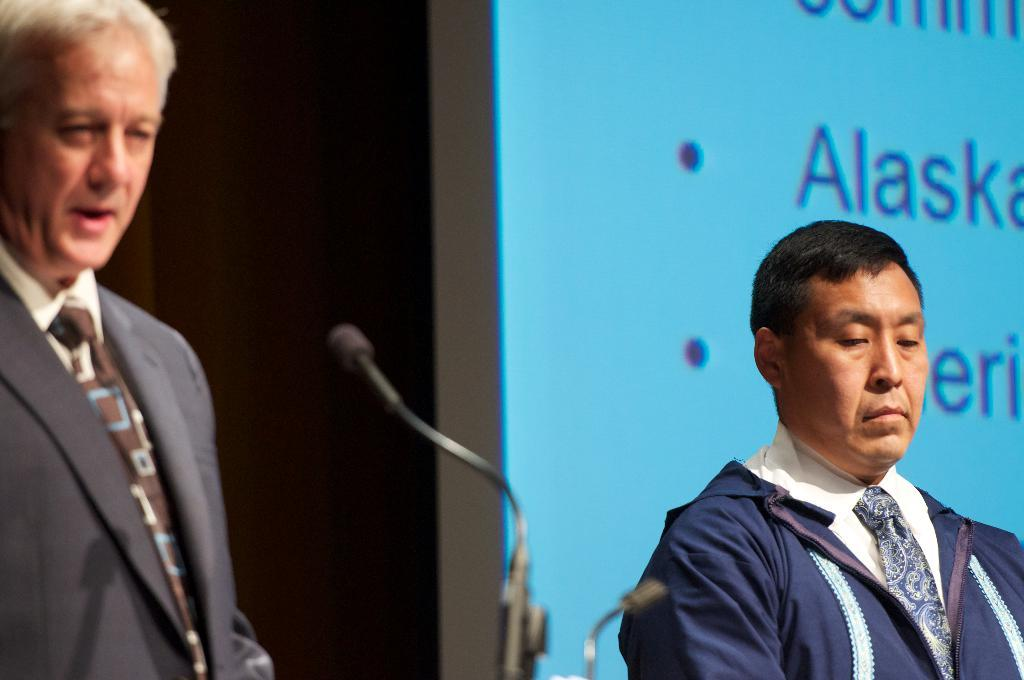What are the people in the image wearing? The persons in the image are wearing clothes. What objects can be seen at the bottom of the image? There are mics at the bottom of the image. What is located on the right side of the image? There is a screen on the right side of the image. What type of horn can be heard in the image? There is no horn present in the image, and therefore no sound can be heard. How does the noise level in the image affect the organization of the event? There is no information about the noise level or an event in the image, so it is not possible to determine its effect on any organization. 